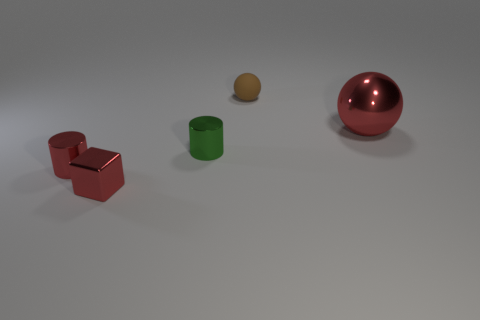Subtract all cubes. How many objects are left? 4 Add 3 large gray things. How many objects exist? 8 Subtract 0 yellow blocks. How many objects are left? 5 Subtract 2 spheres. How many spheres are left? 0 Subtract all gray blocks. Subtract all green cylinders. How many blocks are left? 1 Subtract all green balls. How many yellow cylinders are left? 0 Subtract all small green rubber cylinders. Subtract all tiny brown spheres. How many objects are left? 4 Add 5 small red metal things. How many small red metal things are left? 7 Add 1 cyan cylinders. How many cyan cylinders exist? 1 